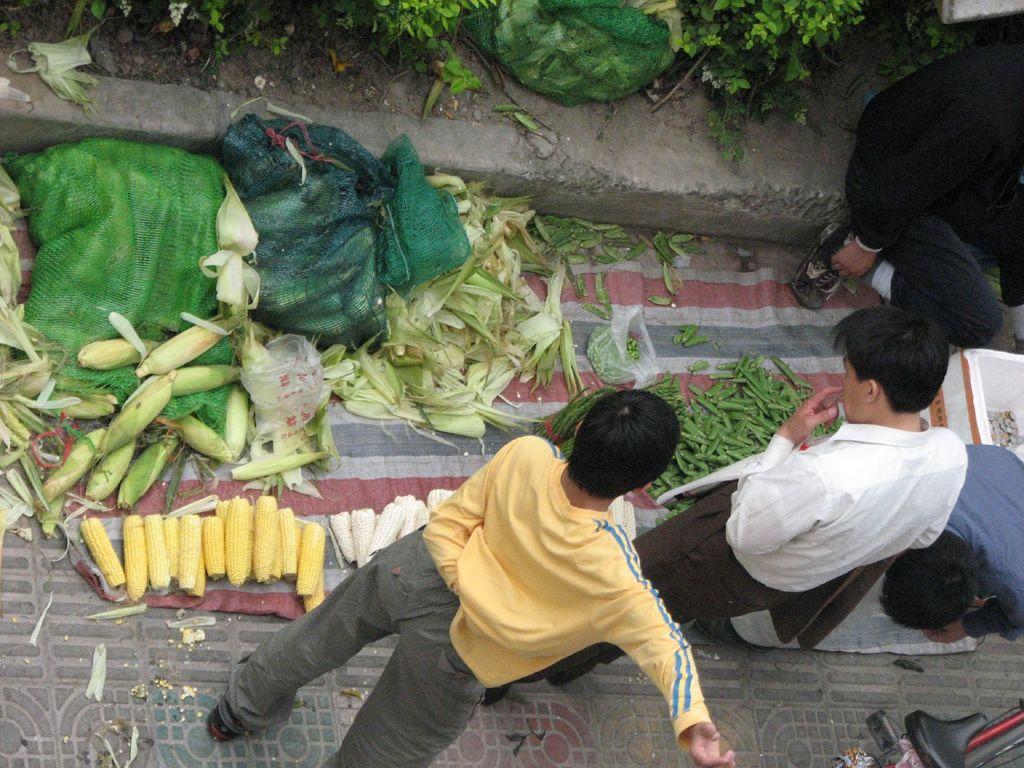How would you summarize this image in a sentence or two? In this image, we can see some people standing and we can see green color food item on the ground. 